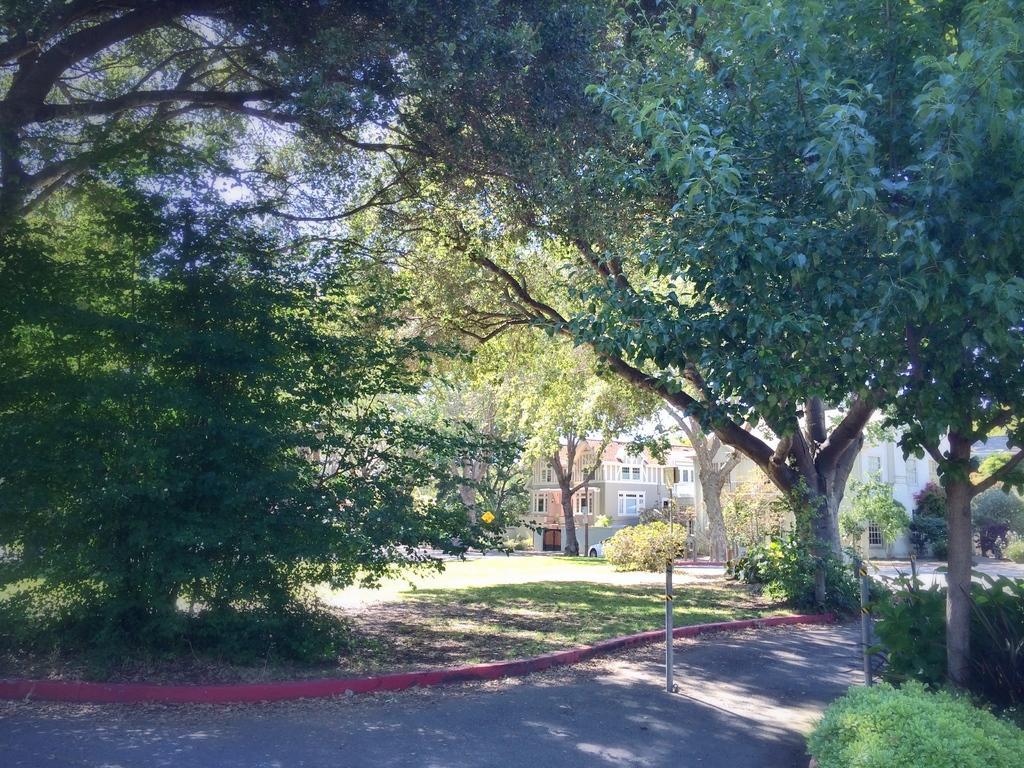Can you describe this image briefly? In this picture I can see the road in front and I see number of trees and in the background I see the buildings and I see a car in front of a building. 